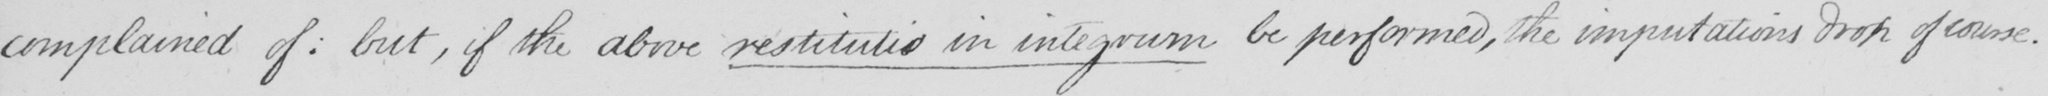Can you read and transcribe this handwriting? complained of :  but , if the above restitutio in integrum be performed , the imputations drop of course . 